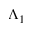Convert formula to latex. <formula><loc_0><loc_0><loc_500><loc_500>\Lambda _ { 1 }</formula> 